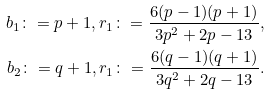<formula> <loc_0><loc_0><loc_500><loc_500>b _ { 1 } \colon = p + 1 , r _ { 1 } \colon = \frac { 6 ( p - 1 ) ( p + 1 ) } { 3 p ^ { 2 } + 2 p - 1 3 } , \\ b _ { 2 } \colon = q + 1 , r _ { 1 } \colon = \frac { 6 ( q - 1 ) ( q + 1 ) } { 3 q ^ { 2 } + 2 q - 1 3 } .</formula> 